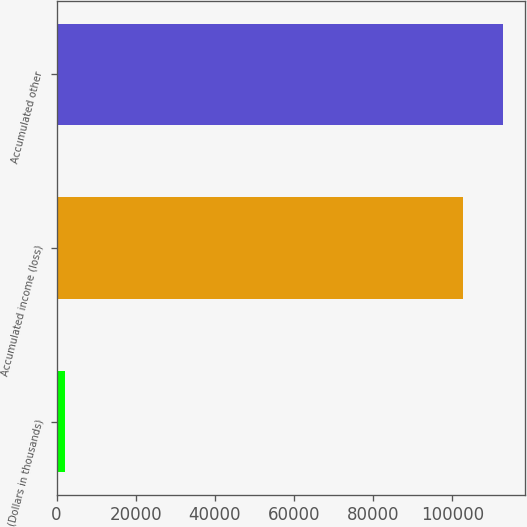Convert chart. <chart><loc_0><loc_0><loc_500><loc_500><bar_chart><fcel>(Dollars in thousands)<fcel>Accumulated income (loss)<fcel>Accumulated other<nl><fcel>2014<fcel>102671<fcel>112739<nl></chart> 